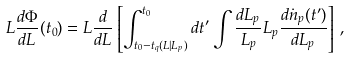<formula> <loc_0><loc_0><loc_500><loc_500>L \frac { d \Phi } { d L } ( t _ { 0 } ) = L \frac { d } { d L } \left [ \int _ { t _ { 0 } - t _ { q } ( L | L _ { p } ) } ^ { t _ { 0 } } d t ^ { \prime } \int \frac { d L _ { p } } { L _ { p } } L _ { p } \frac { d \dot { n } _ { p } ( t ^ { \prime } ) } { d L _ { p } } \right ] \, ,</formula> 